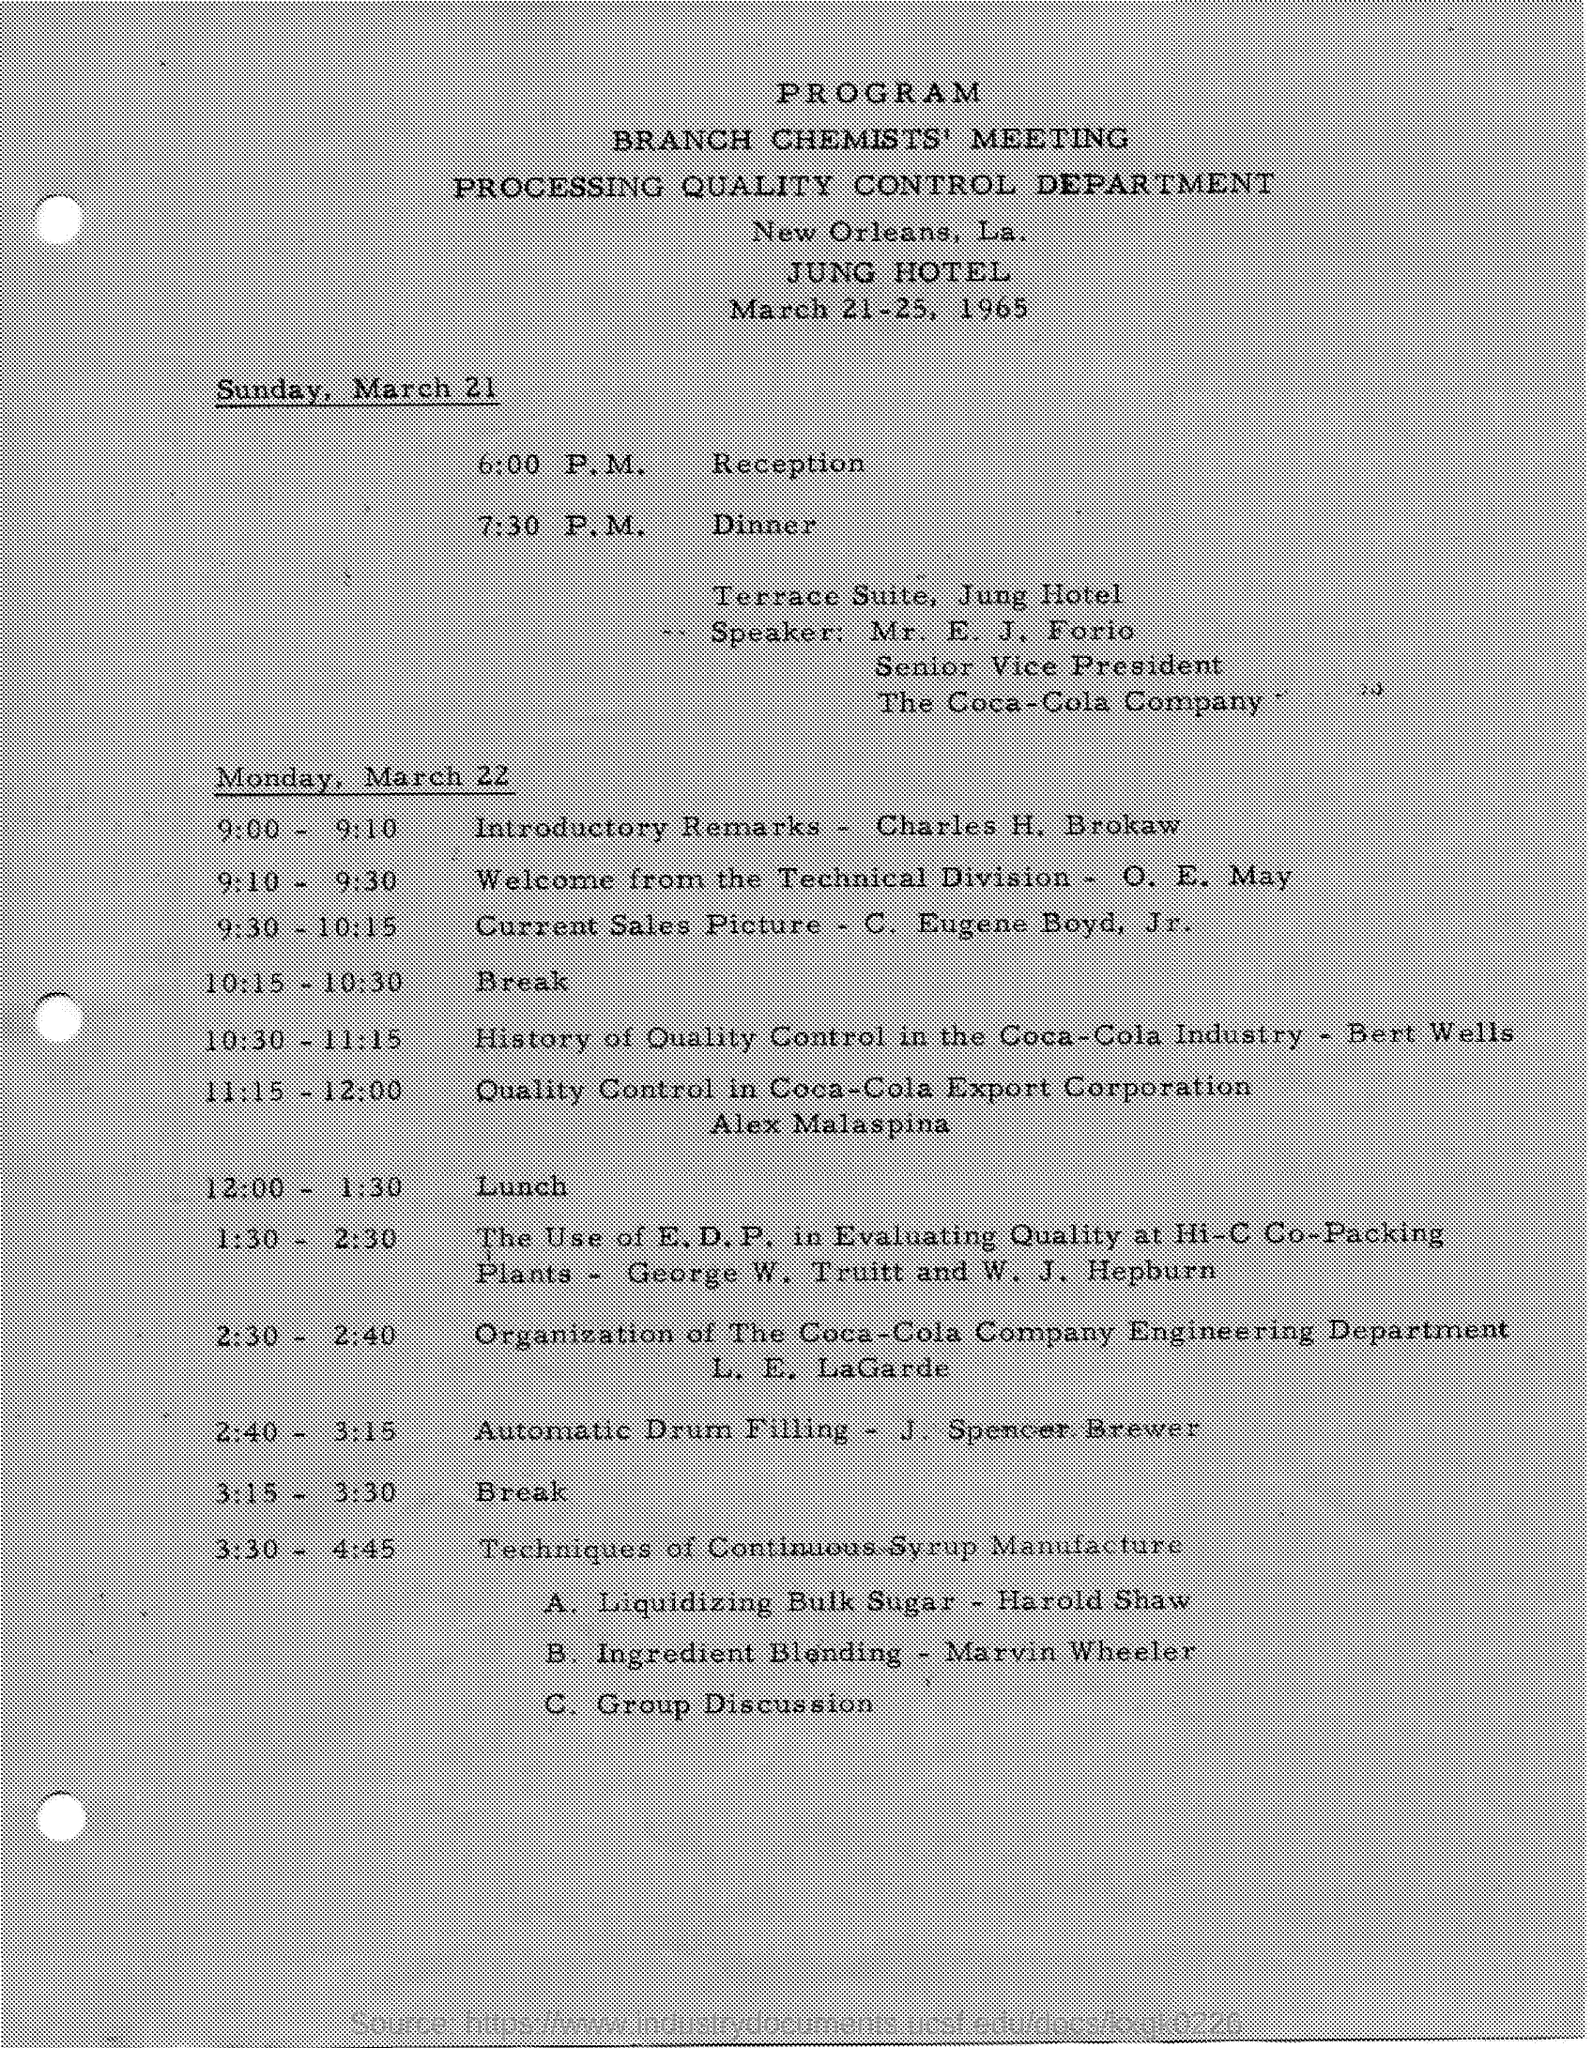Outline some significant characteristics in this image. J. Spencer Brewer's topic from 2:40 to 3:15 was the topic of automatic drum filling. The meeting will be held at the Jung Hotel. Forio is the Senior Vice President of The Coca-Cola Company. E. J. Forio holds the designation of Senior Vice President. On March 22, Charles H. Brokaw will give the Introductory Remarks. 